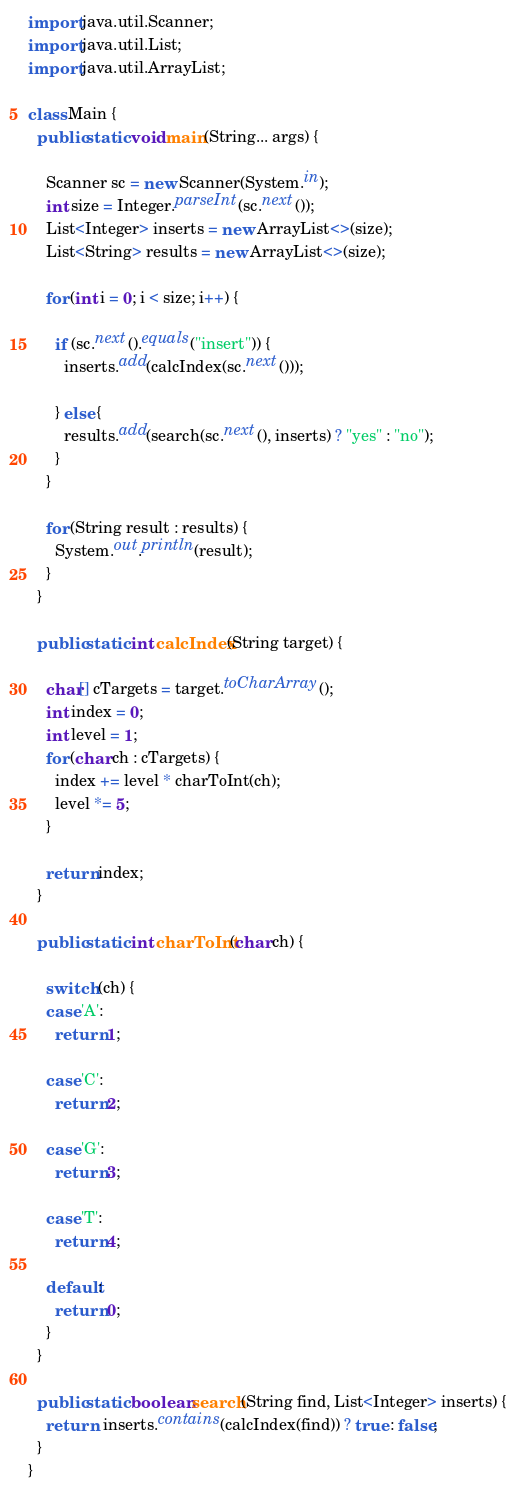Convert code to text. <code><loc_0><loc_0><loc_500><loc_500><_Java_>import java.util.Scanner;
import java.util.List;
import java.util.ArrayList;

class Main {
  public static void main(String... args) {

    Scanner sc = new Scanner(System.in);
    int size = Integer.parseInt(sc.next());
    List<Integer> inserts = new ArrayList<>(size);
    List<String> results = new ArrayList<>(size);

    for (int i = 0; i < size; i++) {

      if (sc.next().equals("insert")) {
        inserts.add(calcIndex(sc.next()));

      } else {
        results.add(search(sc.next(), inserts) ? "yes" : "no");
      }
    }

    for (String result : results) {
      System.out.println(result);
    }
  }

  public static int calcIndex(String target) {

    char[] cTargets = target.toCharArray();
    int index = 0;
    int level = 1;
    for (char ch : cTargets) {
      index += level * charToInt(ch);
      level *= 5;
    }

    return index;
  }

  public static int charToInt(char ch) {

    switch (ch) {
    case 'A':
      return 1;

    case 'C':
      return 2;

    case 'G':
      return 3;

    case 'T':
      return 4;

    default:
      return 0;
    }
  }

  public static boolean search(String find, List<Integer> inserts) {
    return  inserts.contains(calcIndex(find)) ? true : false;
  }
}

</code> 